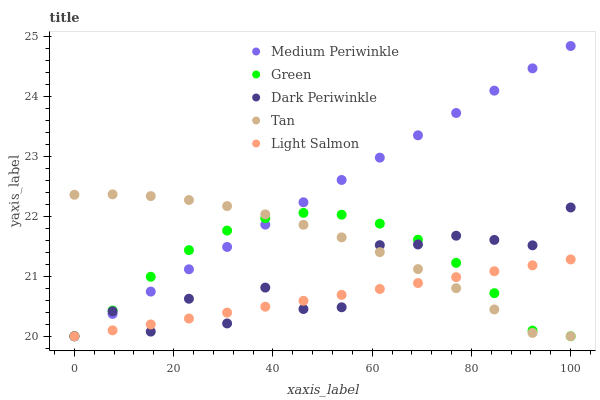Does Light Salmon have the minimum area under the curve?
Answer yes or no. Yes. Does Medium Periwinkle have the maximum area under the curve?
Answer yes or no. Yes. Does Tan have the minimum area under the curve?
Answer yes or no. No. Does Tan have the maximum area under the curve?
Answer yes or no. No. Is Light Salmon the smoothest?
Answer yes or no. Yes. Is Dark Periwinkle the roughest?
Answer yes or no. Yes. Is Tan the smoothest?
Answer yes or no. No. Is Tan the roughest?
Answer yes or no. No. Does Green have the lowest value?
Answer yes or no. Yes. Does Medium Periwinkle have the highest value?
Answer yes or no. Yes. Does Tan have the highest value?
Answer yes or no. No. Does Dark Periwinkle intersect Medium Periwinkle?
Answer yes or no. Yes. Is Dark Periwinkle less than Medium Periwinkle?
Answer yes or no. No. Is Dark Periwinkle greater than Medium Periwinkle?
Answer yes or no. No. 